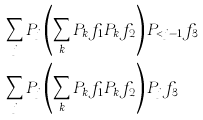Convert formula to latex. <formula><loc_0><loc_0><loc_500><loc_500>& \sum _ { j } P _ { j } \left ( \sum _ { k } P _ { k } f _ { 1 } P _ { k } f _ { 2 } \right ) P _ { < j - 1 } f _ { 3 } \\ & \sum _ { j } P _ { j } \left ( \sum _ { k } P _ { k } f _ { 1 } P _ { k } f _ { 2 } \right ) P _ { j } f _ { 3 }</formula> 